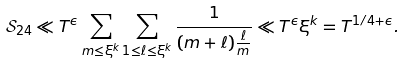<formula> <loc_0><loc_0><loc_500><loc_500>\mathcal { S } _ { 2 4 } \ll T ^ { \epsilon } \sum _ { m \leq \xi ^ { k } } \sum _ { 1 \leq \ell \leq \xi ^ { k } } \frac { 1 } { ( m + \ell ) \frac { \ell } { m } } \ll T ^ { \epsilon } \xi ^ { k } = T ^ { 1 / 4 + \epsilon } .</formula> 